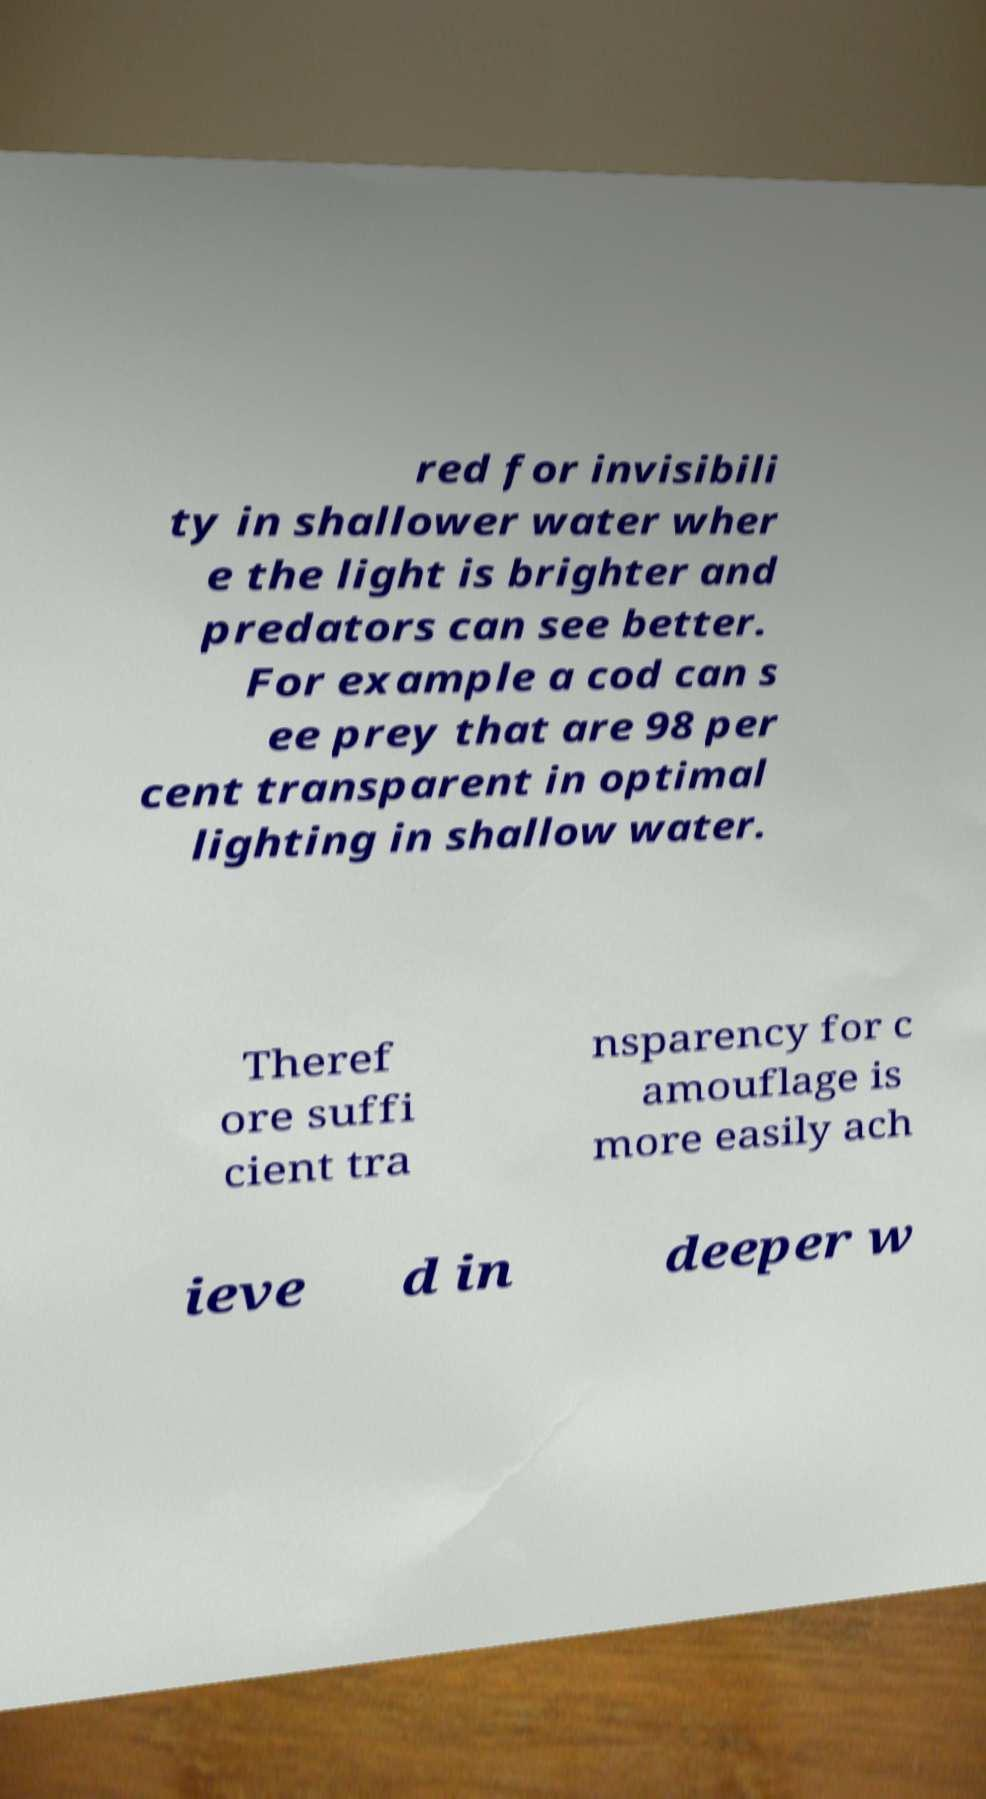Please read and relay the text visible in this image. What does it say? red for invisibili ty in shallower water wher e the light is brighter and predators can see better. For example a cod can s ee prey that are 98 per cent transparent in optimal lighting in shallow water. Theref ore suffi cient tra nsparency for c amouflage is more easily ach ieve d in deeper w 